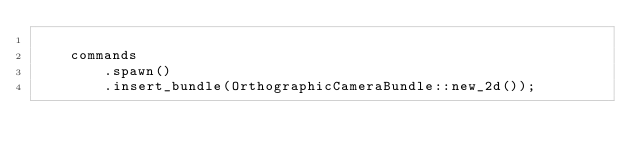Convert code to text. <code><loc_0><loc_0><loc_500><loc_500><_Rust_>
    commands
        .spawn()
        .insert_bundle(OrthographicCameraBundle::new_2d());
</code> 